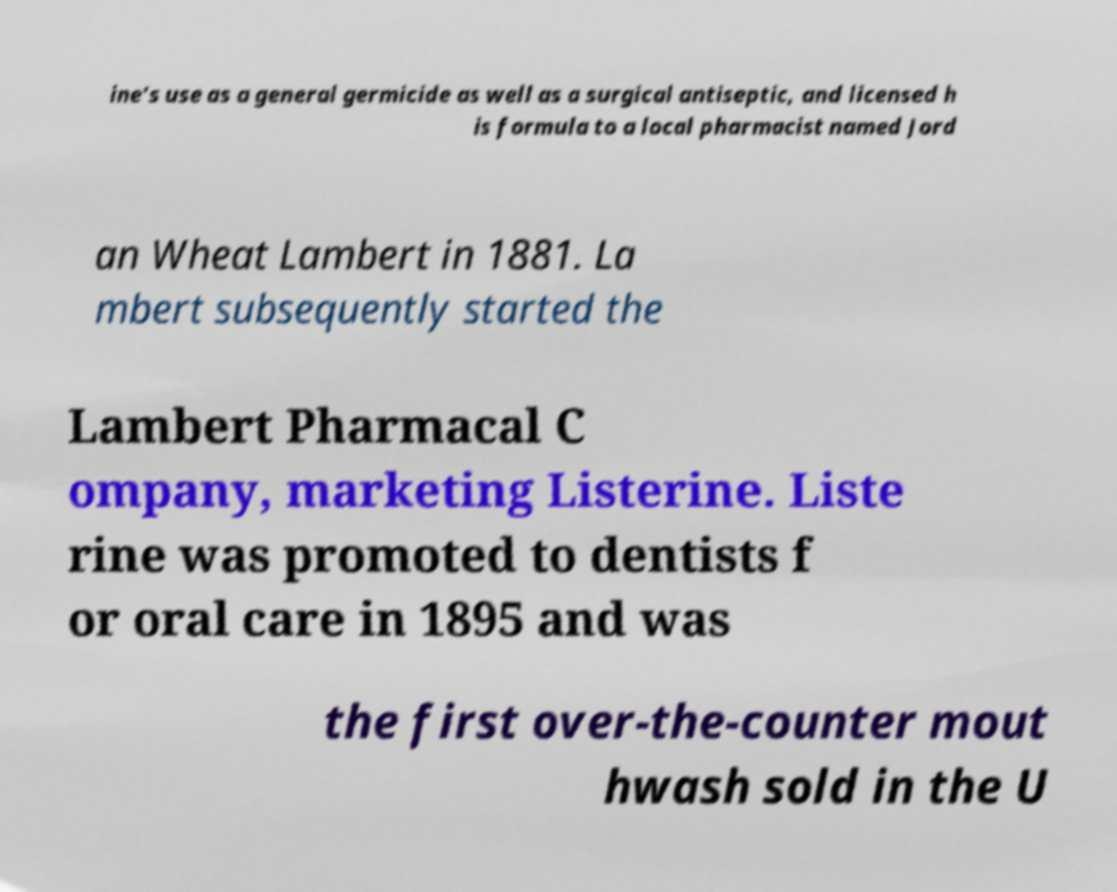Can you read and provide the text displayed in the image?This photo seems to have some interesting text. Can you extract and type it out for me? ine's use as a general germicide as well as a surgical antiseptic, and licensed h is formula to a local pharmacist named Jord an Wheat Lambert in 1881. La mbert subsequently started the Lambert Pharmacal C ompany, marketing Listerine. Liste rine was promoted to dentists f or oral care in 1895 and was the first over-the-counter mout hwash sold in the U 